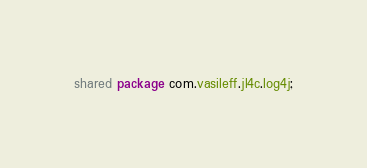<code> <loc_0><loc_0><loc_500><loc_500><_Ceylon_>shared package com.vasileff.jl4c.log4j;
</code> 